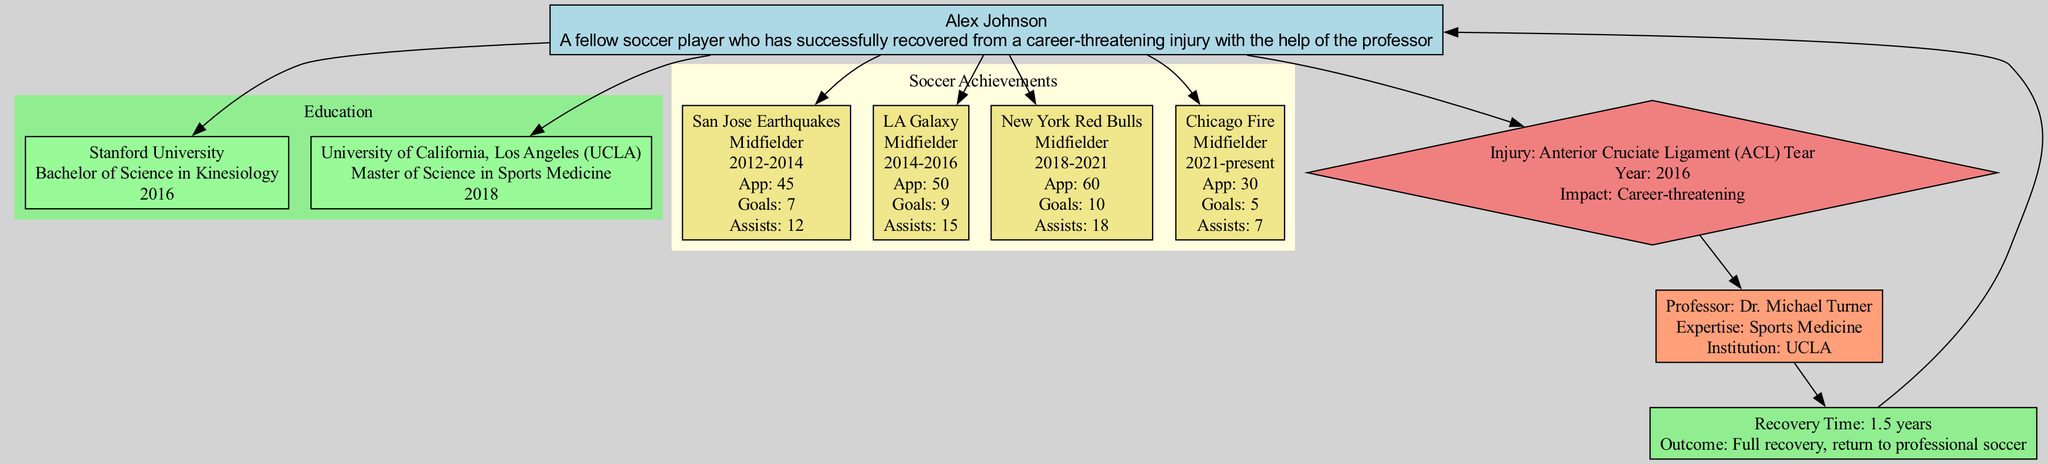What is the degree obtained by Alex Johnson at Stanford University? The diagram specifies that Alex Johnson obtained a "Bachelor of Science in Kinesiology" at Stanford University. This information is found in the education cluster under the Stanford University node.
Answer: Bachelor of Science in Kinesiology How many years did Alex play for the San Jose Earthquakes? The diagram shows that Alex played for the San Jose Earthquakes from 2012 to 2014, which is a total of 2 years. I calculated this by subtracting 2012 from 2014.
Answer: 2 years What injury did Alex Johnson recover from? According to the injury node in the diagram, Alex Johnson recovered from an "Anterior Cruciate Ligament (ACL) Tear." This information is directly stated in the injury section.
Answer: Anterior Cruciate Ligament (ACL) Tear How many goals did Alex score while playing for LA Galaxy? The league achievement node for LA Galaxy explicitly states that Alex scored "9" goals during his time with that club. This number is located in the soccer achievements section connected to the LA Galaxy node.
Answer: 9 Which professor helped Alex with his recovery? The diagram identifies "Dr. Michael Turner" as the professor who assisted Alex in his recovery. This is mentioned under the professor node, connected to the recovery details.
Answer: Dr. Michael Turner What was the total number of appearances Alex made for New York Red Bulls? According to the New York Red Bulls node in the post-recovery achievements, Alex made "60" appearances while playing for this club. This number is located in the highlights section of the respective node.
Answer: 60 How long did Alex take to fully recover from his injury? The recovery time section of the diagram specifies that Alex took "1.5 years" for a full recovery. This information can be found in the recovery node connected to the injury.
Answer: 1.5 years What position did Alex play at Chicago Fire? The diagram indicates that Alex plays the position of "Midfielder" while at Chicago Fire, which is stated in the soccer achievements for that club.
Answer: Midfielder Which institution awarded Alex a Master’s degree? The diagram indicates that Alex obtained his Master of Science in Sports Medicine from the "University of California, Los Angeles (UCLA)." This is mentioned in the educational background section.
Answer: University of California, Los Angeles (UCLA) 